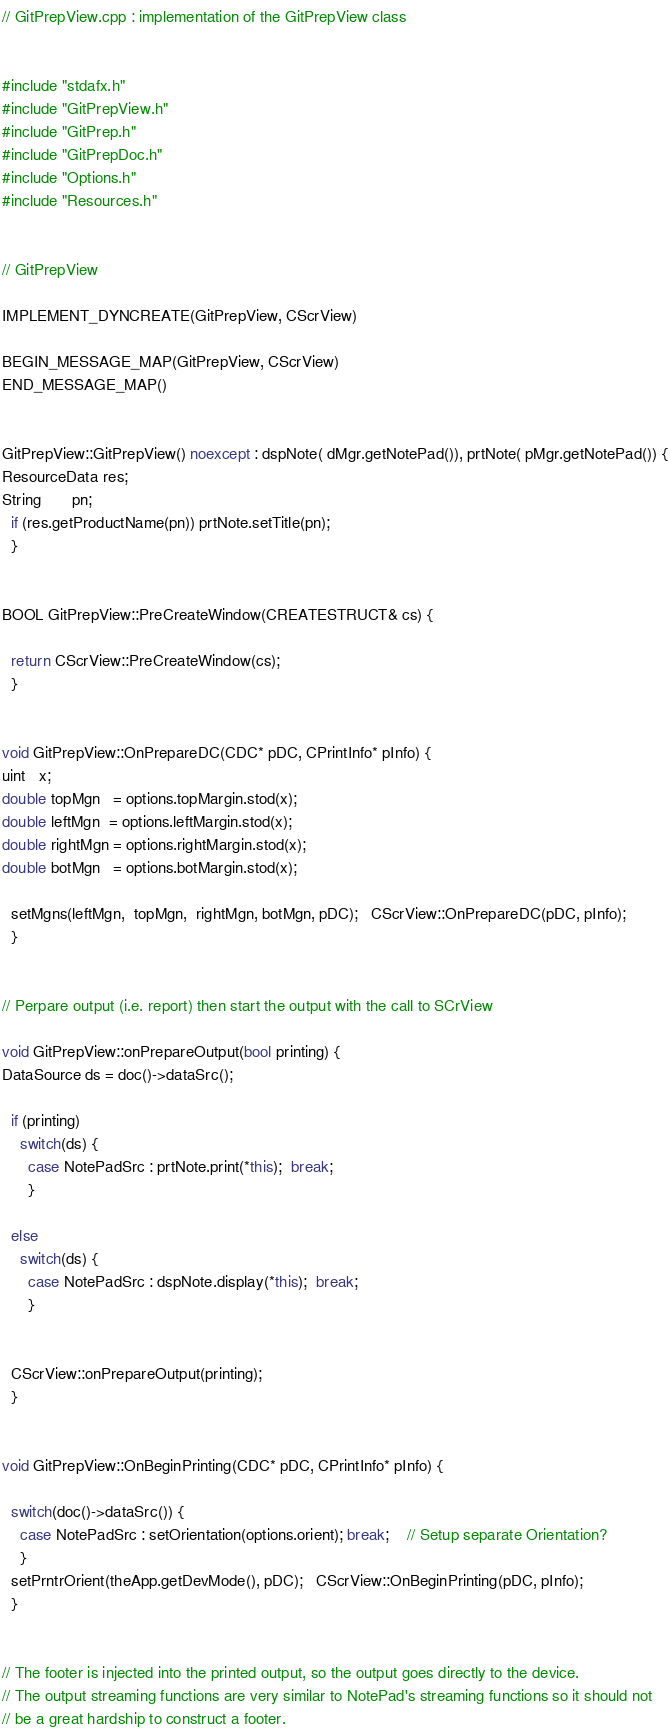Convert code to text. <code><loc_0><loc_0><loc_500><loc_500><_C++_>// GitPrepView.cpp : implementation of the GitPrepView class


#include "stdafx.h"
#include "GitPrepView.h"
#include "GitPrep.h"
#include "GitPrepDoc.h"
#include "Options.h"
#include "Resources.h"


// GitPrepView

IMPLEMENT_DYNCREATE(GitPrepView, CScrView)

BEGIN_MESSAGE_MAP(GitPrepView, CScrView)
END_MESSAGE_MAP()


GitPrepView::GitPrepView() noexcept : dspNote( dMgr.getNotePad()), prtNote( pMgr.getNotePad()) {
ResourceData res;
String       pn;
  if (res.getProductName(pn)) prtNote.setTitle(pn);
  }


BOOL GitPrepView::PreCreateWindow(CREATESTRUCT& cs) {

  return CScrView::PreCreateWindow(cs);
  }


void GitPrepView::OnPrepareDC(CDC* pDC, CPrintInfo* pInfo) {
uint   x;
double topMgn   = options.topMargin.stod(x);
double leftMgn  = options.leftMargin.stod(x);
double rightMgn = options.rightMargin.stod(x);
double botMgn   = options.botMargin.stod(x);

  setMgns(leftMgn,  topMgn,  rightMgn, botMgn, pDC);   CScrView::OnPrepareDC(pDC, pInfo);
  }


// Perpare output (i.e. report) then start the output with the call to SCrView

void GitPrepView::onPrepareOutput(bool printing) {
DataSource ds = doc()->dataSrc();

  if (printing)
    switch(ds) {
      case NotePadSrc : prtNote.print(*this);  break;
      }

  else
    switch(ds) {
      case NotePadSrc : dspNote.display(*this);  break;
      }


  CScrView::onPrepareOutput(printing);
  }


void GitPrepView::OnBeginPrinting(CDC* pDC, CPrintInfo* pInfo) {

  switch(doc()->dataSrc()) {
    case NotePadSrc : setOrientation(options.orient); break;    // Setup separate Orientation?
    }
  setPrntrOrient(theApp.getDevMode(), pDC);   CScrView::OnBeginPrinting(pDC, pInfo);
  }


// The footer is injected into the printed output, so the output goes directly to the device.
// The output streaming functions are very similar to NotePad's streaming functions so it should not
// be a great hardship to construct a footer.
</code> 